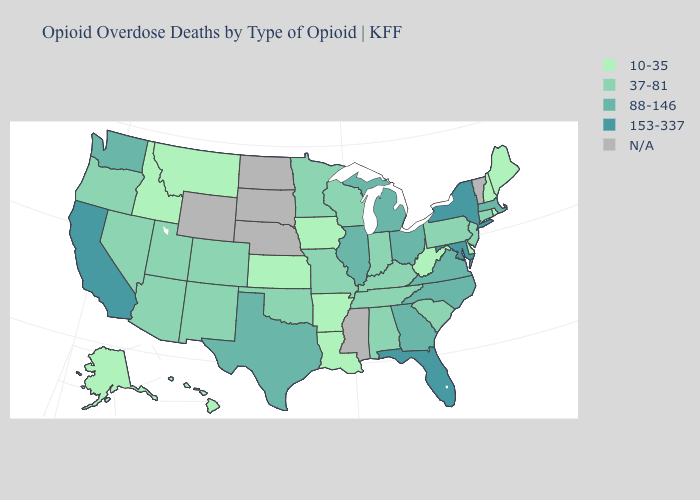Does the first symbol in the legend represent the smallest category?
Give a very brief answer. Yes. Does the first symbol in the legend represent the smallest category?
Concise answer only. Yes. Which states have the highest value in the USA?
Quick response, please. California, Florida, Maryland, New York. Does New Hampshire have the lowest value in the Northeast?
Short answer required. Yes. What is the value of Tennessee?
Short answer required. 37-81. What is the value of Washington?
Keep it brief. 88-146. Name the states that have a value in the range 10-35?
Be succinct. Alaska, Arkansas, Delaware, Hawaii, Idaho, Iowa, Kansas, Louisiana, Maine, Montana, New Hampshire, Rhode Island, West Virginia. How many symbols are there in the legend?
Give a very brief answer. 5. What is the value of Louisiana?
Quick response, please. 10-35. What is the value of North Dakota?
Be succinct. N/A. Among the states that border Mississippi , which have the highest value?
Quick response, please. Alabama, Tennessee. Which states have the lowest value in the South?
Write a very short answer. Arkansas, Delaware, Louisiana, West Virginia. Name the states that have a value in the range 88-146?
Concise answer only. Georgia, Illinois, Massachusetts, Michigan, North Carolina, Ohio, Texas, Virginia, Washington. What is the highest value in the Northeast ?
Short answer required. 153-337. 